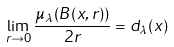<formula> <loc_0><loc_0><loc_500><loc_500>\lim _ { r \to 0 } \frac { \mu _ { \lambda } ( B ( x , r ) ) } { 2 r } = d _ { \lambda } ( x )</formula> 